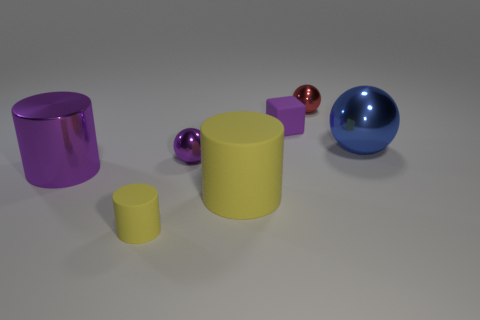Add 1 small red things. How many objects exist? 8 Subtract all cubes. How many objects are left? 6 Subtract all small green blocks. Subtract all large blue spheres. How many objects are left? 6 Add 1 red spheres. How many red spheres are left? 2 Add 3 large blue spheres. How many large blue spheres exist? 4 Subtract 0 yellow spheres. How many objects are left? 7 